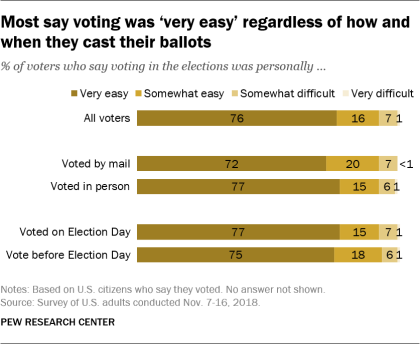Draw attention to some important aspects in this diagram. In general, 76% of people prefer very easy level when given the option to choose. The method with the highest level of customer satisfaction is the one that was voted on Election Day. 